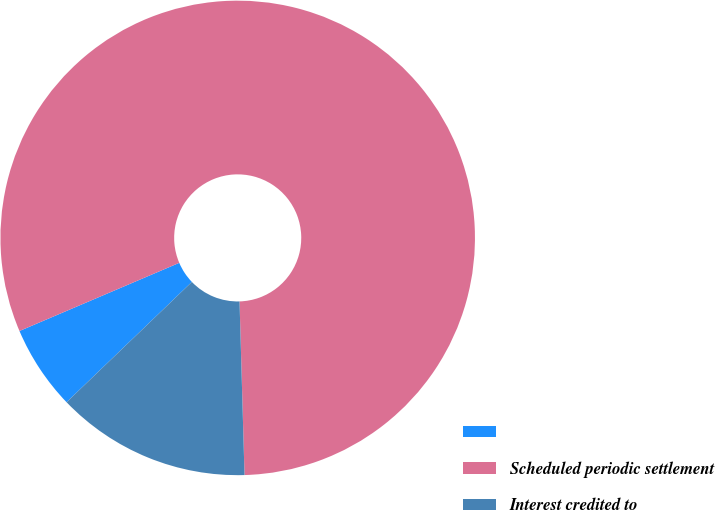<chart> <loc_0><loc_0><loc_500><loc_500><pie_chart><ecel><fcel>Scheduled periodic settlement<fcel>Interest credited to<nl><fcel>5.76%<fcel>80.96%<fcel>13.28%<nl></chart> 